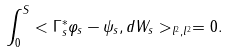Convert formula to latex. <formula><loc_0><loc_0><loc_500><loc_500>\int _ { 0 } ^ { S } < \Gamma ^ { \ast } _ { s } \varphi _ { s } - \psi _ { s } , d W _ { s } > _ { l ^ { 2 } , l ^ { 2 } } = 0 .</formula> 